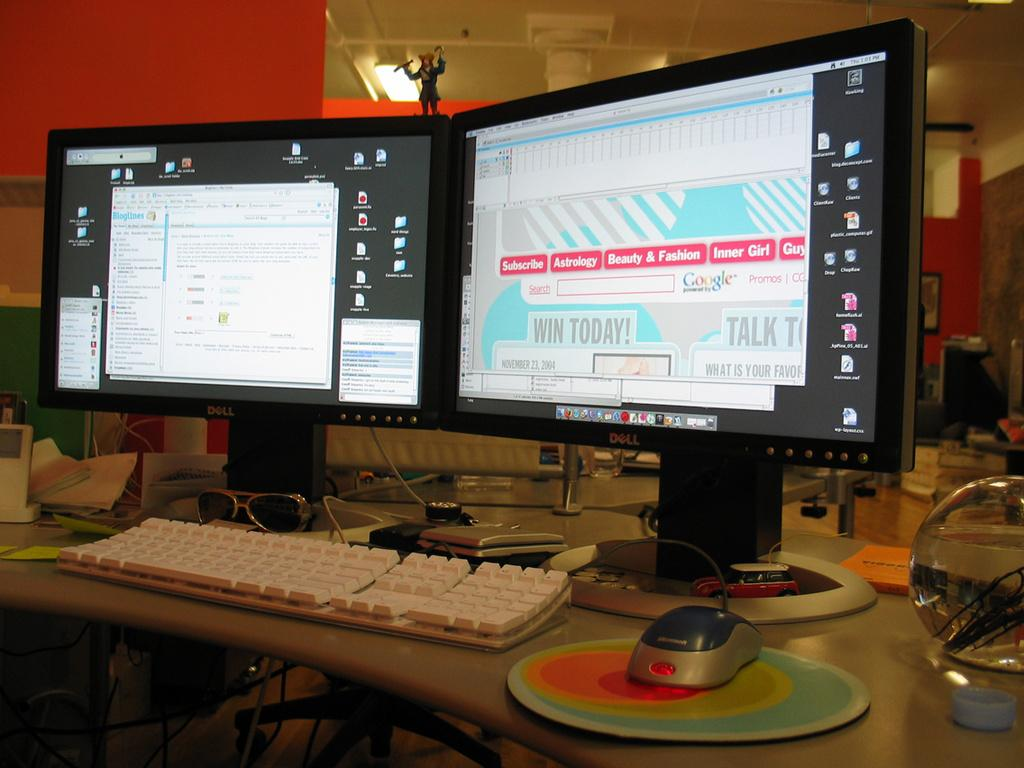<image>
Create a compact narrative representing the image presented. Two computer screens, one with received email, the other with an open sweepstakes email. 